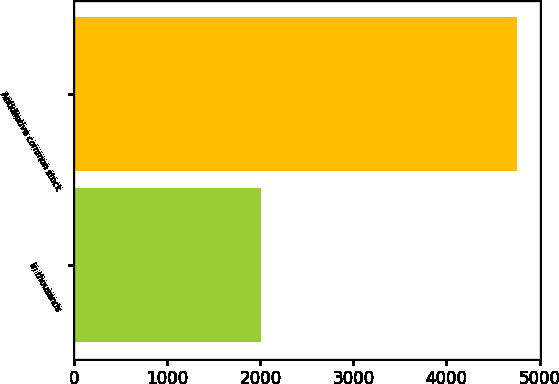Convert chart. <chart><loc_0><loc_0><loc_500><loc_500><bar_chart><fcel>in thousands<fcel>Antidilutive common stock<nl><fcel>2012<fcel>4762<nl></chart> 